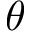<formula> <loc_0><loc_0><loc_500><loc_500>\theta</formula> 